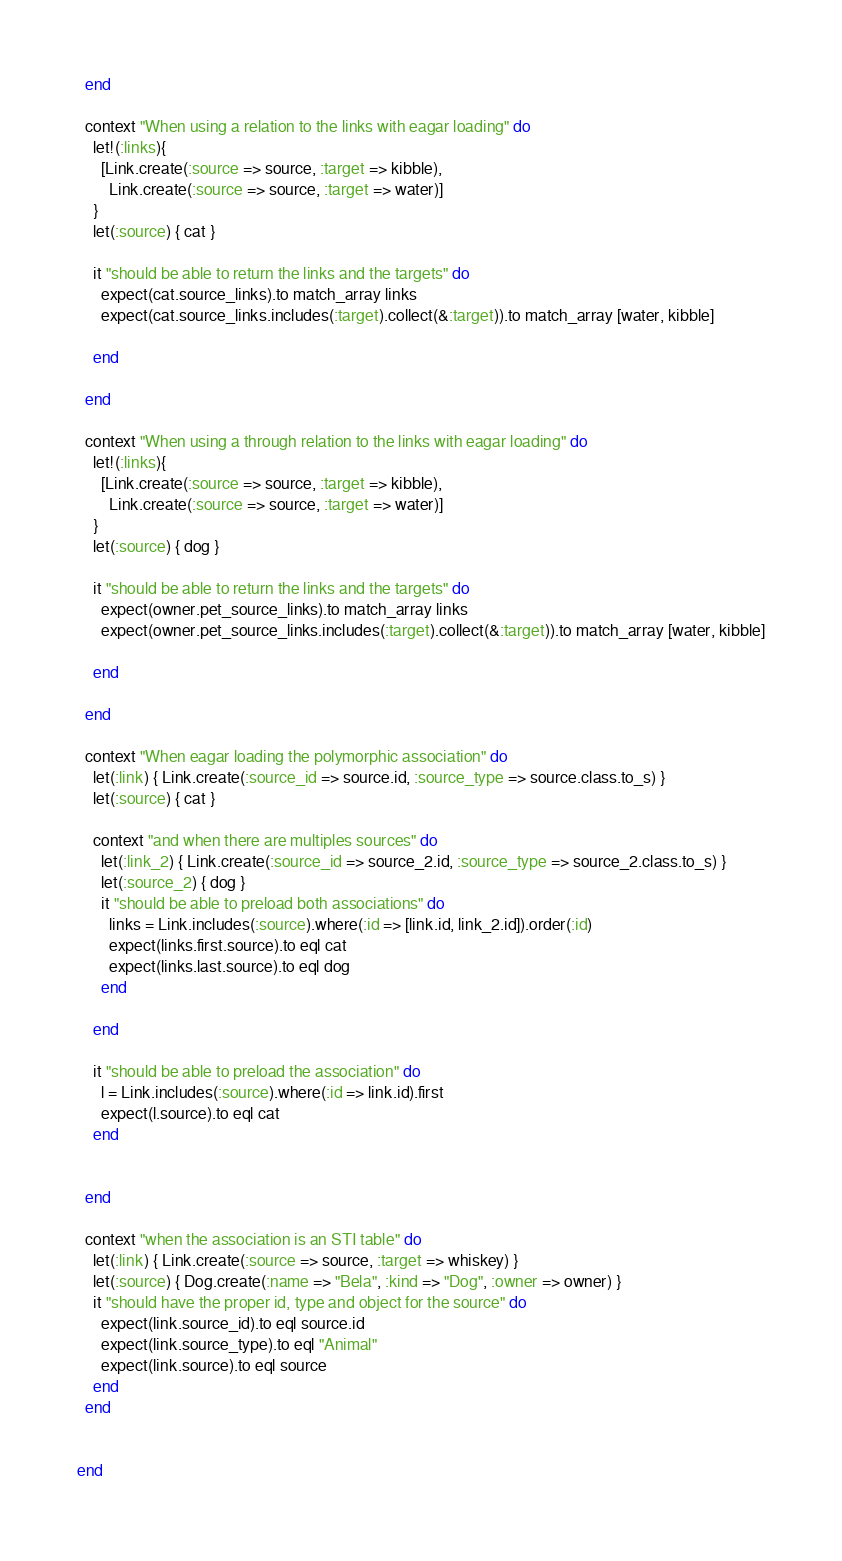<code> <loc_0><loc_0><loc_500><loc_500><_Ruby_>  end

  context "When using a relation to the links with eagar loading" do
    let!(:links){
      [Link.create(:source => source, :target => kibble),
        Link.create(:source => source, :target => water)]
    }
    let(:source) { cat }

    it "should be able to return the links and the targets" do
      expect(cat.source_links).to match_array links
      expect(cat.source_links.includes(:target).collect(&:target)).to match_array [water, kibble]

    end

  end

  context "When using a through relation to the links with eagar loading" do
    let!(:links){
      [Link.create(:source => source, :target => kibble),
        Link.create(:source => source, :target => water)]
    }
    let(:source) { dog }

    it "should be able to return the links and the targets" do
      expect(owner.pet_source_links).to match_array links
      expect(owner.pet_source_links.includes(:target).collect(&:target)).to match_array [water, kibble]

    end

  end

  context "When eagar loading the polymorphic association" do
    let(:link) { Link.create(:source_id => source.id, :source_type => source.class.to_s) }
    let(:source) { cat }

    context "and when there are multiples sources" do
      let(:link_2) { Link.create(:source_id => source_2.id, :source_type => source_2.class.to_s) }
      let(:source_2) { dog }
      it "should be able to preload both associations" do
        links = Link.includes(:source).where(:id => [link.id, link_2.id]).order(:id)
        expect(links.first.source).to eql cat
        expect(links.last.source).to eql dog
      end

    end

    it "should be able to preload the association" do
      l = Link.includes(:source).where(:id => link.id).first
      expect(l.source).to eql cat
    end


  end
  
  context "when the association is an STI table" do
    let(:link) { Link.create(:source => source, :target => whiskey) }
    let(:source) { Dog.create(:name => "Bela", :kind => "Dog", :owner => owner) }
    it "should have the proper id, type and object for the source" do
      expect(link.source_id).to eql source.id
      expect(link.source_type).to eql "Animal"
      expect(link.source).to eql source
    end
  end
  

end
</code> 